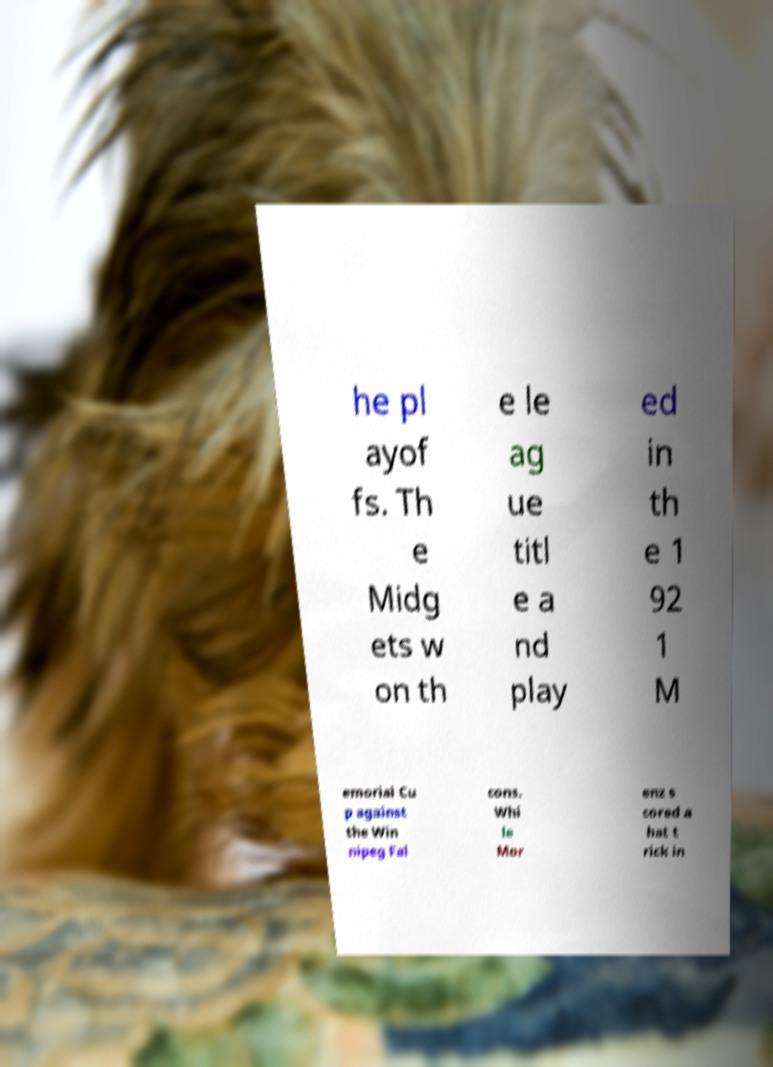Can you read and provide the text displayed in the image?This photo seems to have some interesting text. Can you extract and type it out for me? he pl ayof fs. Th e Midg ets w on th e le ag ue titl e a nd play ed in th e 1 92 1 M emorial Cu p against the Win nipeg Fal cons. Whi le Mor enz s cored a hat t rick in 